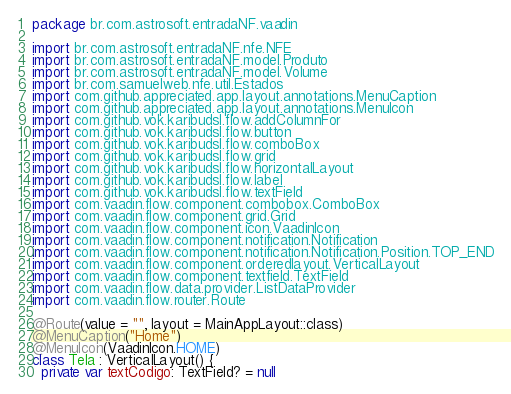<code> <loc_0><loc_0><loc_500><loc_500><_Kotlin_>package br.com.astrosoft.entradaNF.vaadin

import br.com.astrosoft.entradaNF.nfe.NFE
import br.com.astrosoft.entradaNF.model.Produto
import br.com.astrosoft.entradaNF.model.Volume
import br.com.samuelweb.nfe.util.Estados
import com.github.appreciated.app.layout.annotations.MenuCaption
import com.github.appreciated.app.layout.annotations.MenuIcon
import com.github.vok.karibudsl.flow.addColumnFor
import com.github.vok.karibudsl.flow.button
import com.github.vok.karibudsl.flow.comboBox
import com.github.vok.karibudsl.flow.grid
import com.github.vok.karibudsl.flow.horizontalLayout
import com.github.vok.karibudsl.flow.label
import com.github.vok.karibudsl.flow.textField
import com.vaadin.flow.component.combobox.ComboBox
import com.vaadin.flow.component.grid.Grid
import com.vaadin.flow.component.icon.VaadinIcon
import com.vaadin.flow.component.notification.Notification
import com.vaadin.flow.component.notification.Notification.Position.TOP_END
import com.vaadin.flow.component.orderedlayout.VerticalLayout
import com.vaadin.flow.component.textfield.TextField
import com.vaadin.flow.data.provider.ListDataProvider
import com.vaadin.flow.router.Route

@Route(value = "", layout = MainAppLayout::class)
@MenuCaption("Home")
@MenuIcon(VaadinIcon.HOME)
class Tela : VerticalLayout() {
  private var textCodigo: TextField? = null</code> 